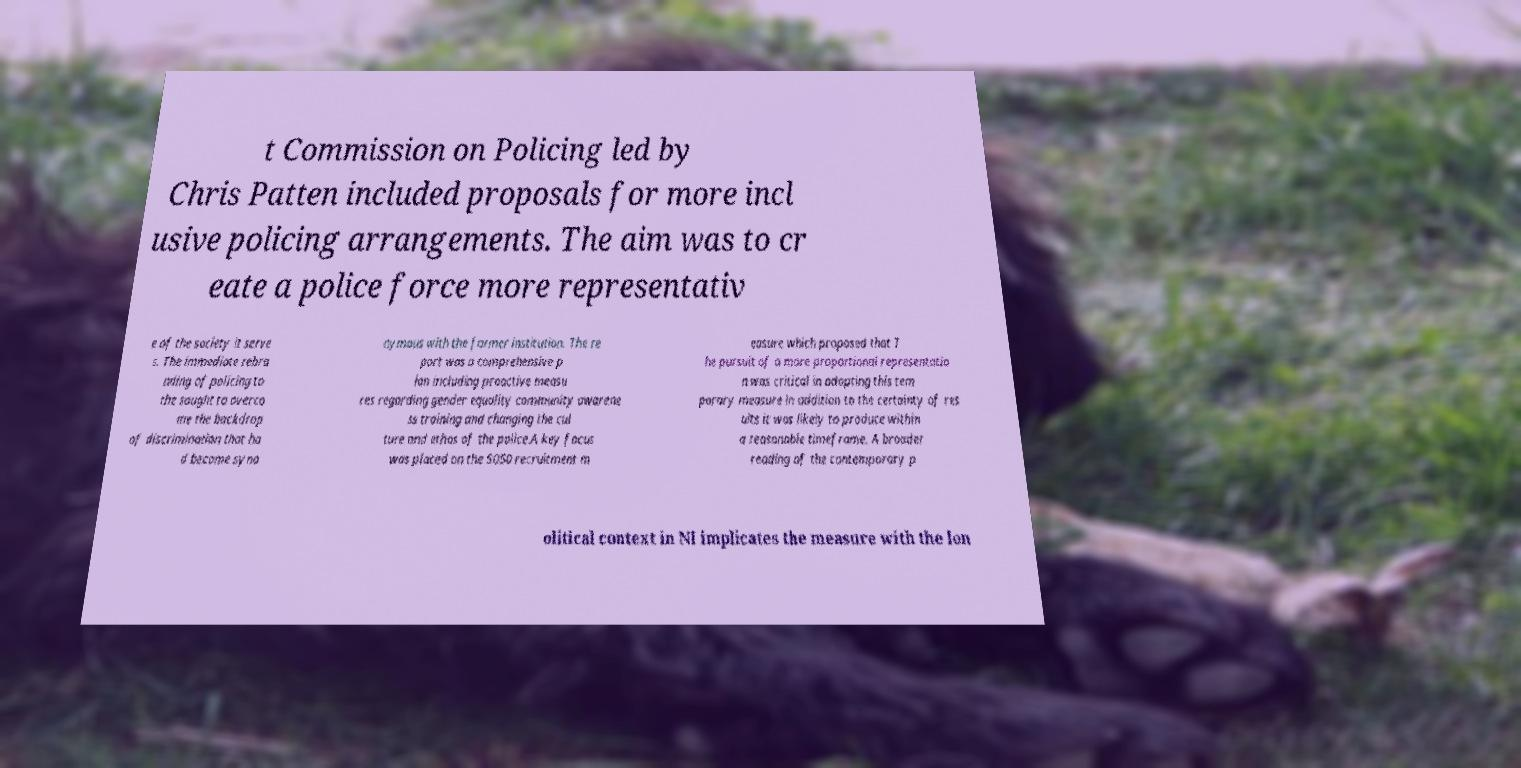For documentation purposes, I need the text within this image transcribed. Could you provide that? t Commission on Policing led by Chris Patten included proposals for more incl usive policing arrangements. The aim was to cr eate a police force more representativ e of the society it serve s. The immediate rebra nding of policing to the sought to overco me the backdrop of discrimination that ha d become syno nymous with the former institution. The re port was a comprehensive p lan including proactive measu res regarding gender equality community awarene ss training and changing the cul ture and ethos of the police.A key focus was placed on the 5050 recruitment m easure which proposed that T he pursuit of a more proportional representatio n was critical in adopting this tem porary measure in addition to the certainty of res ults it was likely to produce within a reasonable timeframe. A broader reading of the contemporary p olitical context in NI implicates the measure with the lon 